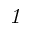<formula> <loc_0><loc_0><loc_500><loc_500>1</formula> 